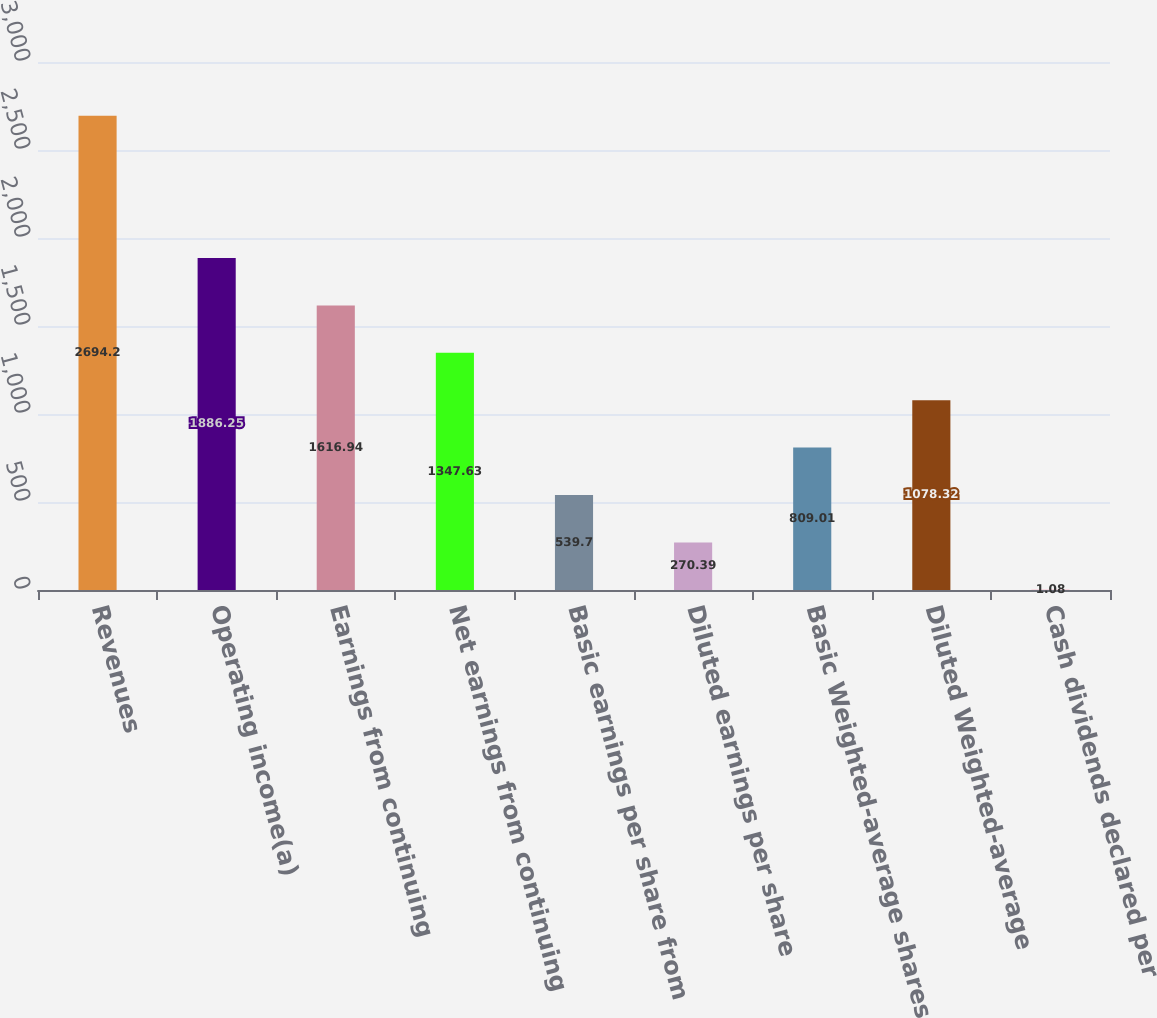<chart> <loc_0><loc_0><loc_500><loc_500><bar_chart><fcel>Revenues<fcel>Operating income(a)<fcel>Earnings from continuing<fcel>Net earnings from continuing<fcel>Basic earnings per share from<fcel>Diluted earnings per share<fcel>Basic Weighted-average shares<fcel>Diluted Weighted-average<fcel>Cash dividends declared per<nl><fcel>2694.2<fcel>1886.25<fcel>1616.94<fcel>1347.63<fcel>539.7<fcel>270.39<fcel>809.01<fcel>1078.32<fcel>1.08<nl></chart> 